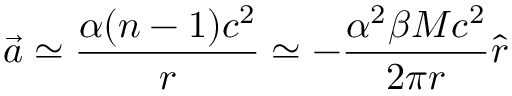<formula> <loc_0><loc_0><loc_500><loc_500>\vec { a } \simeq \frac { \alpha ( n - 1 ) c ^ { 2 } } { r } \simeq - \frac { \alpha ^ { 2 } \beta M c ^ { 2 } } { 2 \pi r } \hat { r }</formula> 